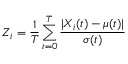Convert formula to latex. <formula><loc_0><loc_0><loc_500><loc_500>Z _ { i } = \frac { 1 } { T } \sum _ { t = 0 } ^ { T } \frac { | X _ { i } ( t ) - \mu ( t ) | } { \sigma ( t ) }</formula> 